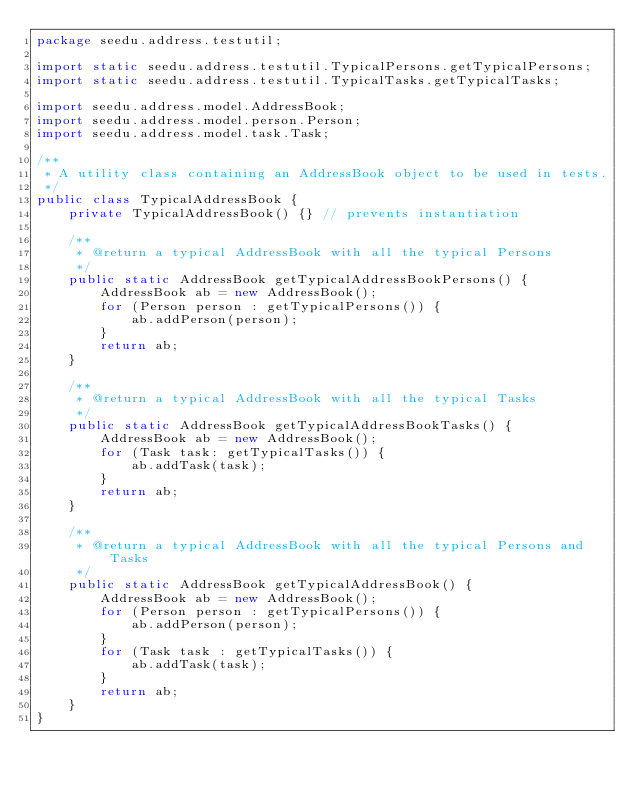Convert code to text. <code><loc_0><loc_0><loc_500><loc_500><_Java_>package seedu.address.testutil;

import static seedu.address.testutil.TypicalPersons.getTypicalPersons;
import static seedu.address.testutil.TypicalTasks.getTypicalTasks;

import seedu.address.model.AddressBook;
import seedu.address.model.person.Person;
import seedu.address.model.task.Task;

/**
 * A utility class containing an AddressBook object to be used in tests.
 */
public class TypicalAddressBook {
    private TypicalAddressBook() {} // prevents instantiation

    /**
     * @return a typical AddressBook with all the typical Persons
     */
    public static AddressBook getTypicalAddressBookPersons() {
        AddressBook ab = new AddressBook();
        for (Person person : getTypicalPersons()) {
            ab.addPerson(person);
        }
        return ab;
    }

    /**
     * @return a typical AddressBook with all the typical Tasks
     */
    public static AddressBook getTypicalAddressBookTasks() {
        AddressBook ab = new AddressBook();
        for (Task task: getTypicalTasks()) {
            ab.addTask(task);
        }
        return ab;
    }

    /**
     * @return a typical AddressBook with all the typical Persons and Tasks
     */
    public static AddressBook getTypicalAddressBook() {
        AddressBook ab = new AddressBook();
        for (Person person : getTypicalPersons()) {
            ab.addPerson(person);
        }
        for (Task task : getTypicalTasks()) {
            ab.addTask(task);
        }
        return ab;
    }
}
</code> 